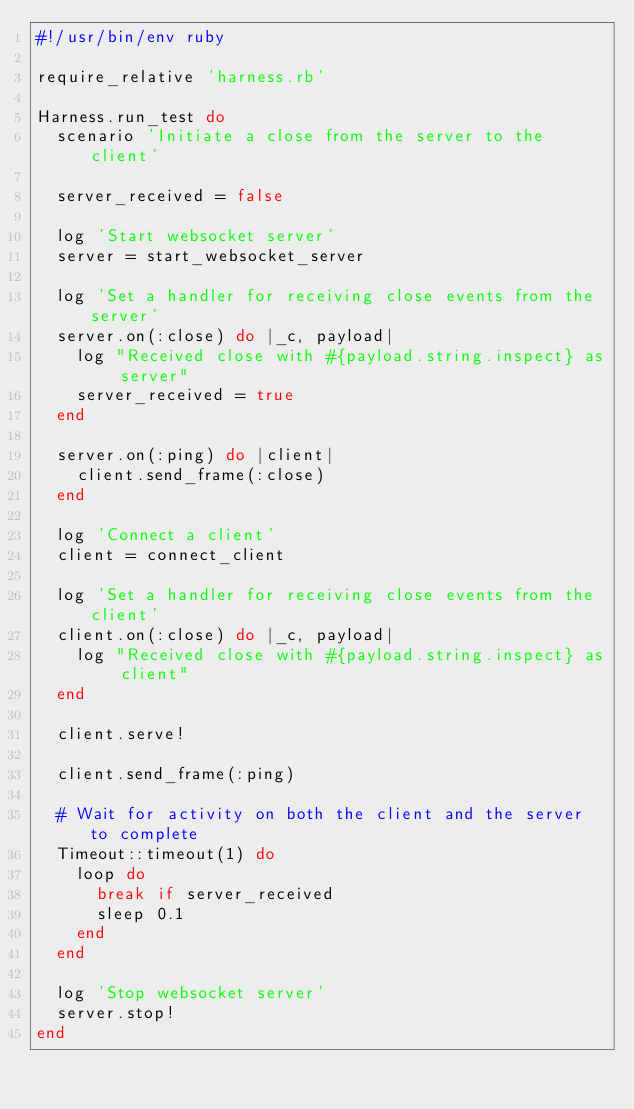Convert code to text. <code><loc_0><loc_0><loc_500><loc_500><_Ruby_>#!/usr/bin/env ruby

require_relative 'harness.rb'

Harness.run_test do
  scenario 'Initiate a close from the server to the client'

  server_received = false

  log 'Start websocket server'
  server = start_websocket_server

  log 'Set a handler for receiving close events from the server'
  server.on(:close) do |_c, payload|
    log "Received close with #{payload.string.inspect} as server"
    server_received = true
  end

  server.on(:ping) do |client|
    client.send_frame(:close)
  end

  log 'Connect a client'
  client = connect_client

  log 'Set a handler for receiving close events from the client'
  client.on(:close) do |_c, payload|
    log "Received close with #{payload.string.inspect} as client"
  end

  client.serve!

  client.send_frame(:ping)

  # Wait for activity on both the client and the server to complete
  Timeout::timeout(1) do
    loop do
      break if server_received
      sleep 0.1
    end
  end

  log 'Stop websocket server'
  server.stop!
end
</code> 